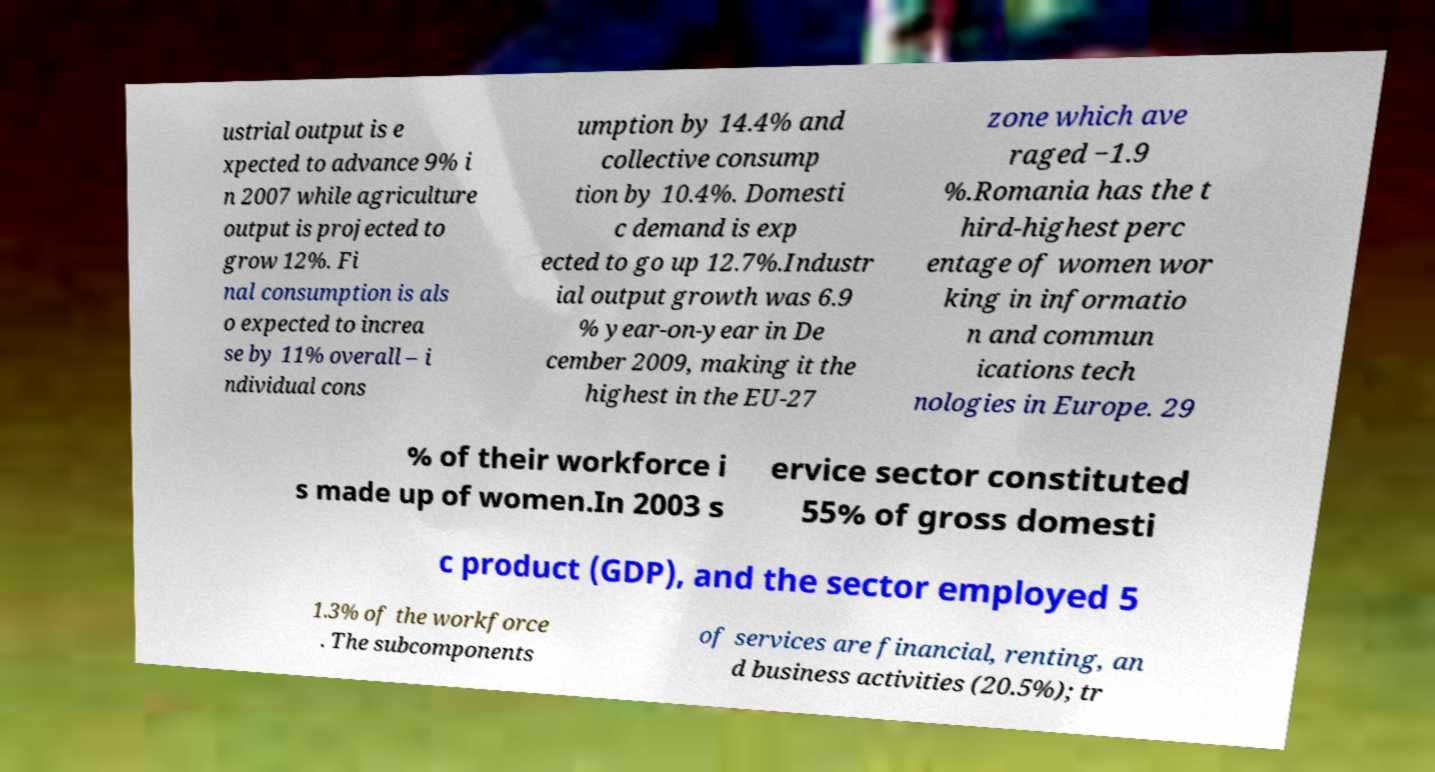Please read and relay the text visible in this image. What does it say? ustrial output is e xpected to advance 9% i n 2007 while agriculture output is projected to grow 12%. Fi nal consumption is als o expected to increa se by 11% overall – i ndividual cons umption by 14.4% and collective consump tion by 10.4%. Domesti c demand is exp ected to go up 12.7%.Industr ial output growth was 6.9 % year-on-year in De cember 2009, making it the highest in the EU-27 zone which ave raged −1.9 %.Romania has the t hird-highest perc entage of women wor king in informatio n and commun ications tech nologies in Europe. 29 % of their workforce i s made up of women.In 2003 s ervice sector constituted 55% of gross domesti c product (GDP), and the sector employed 5 1.3% of the workforce . The subcomponents of services are financial, renting, an d business activities (20.5%); tr 